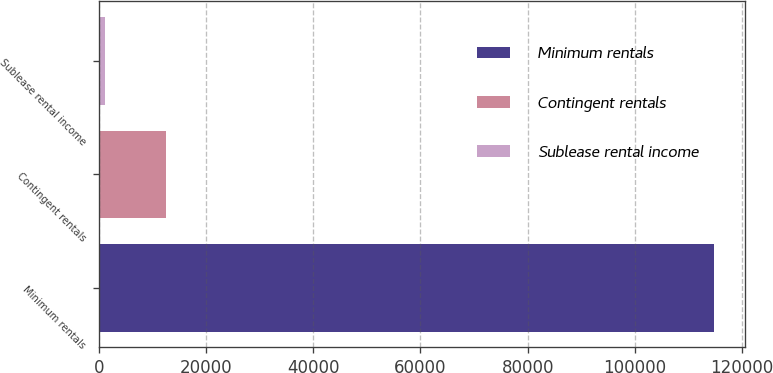<chart> <loc_0><loc_0><loc_500><loc_500><bar_chart><fcel>Minimum rentals<fcel>Contingent rentals<fcel>Sublease rental income<nl><fcel>114750<fcel>12579.3<fcel>1227<nl></chart> 